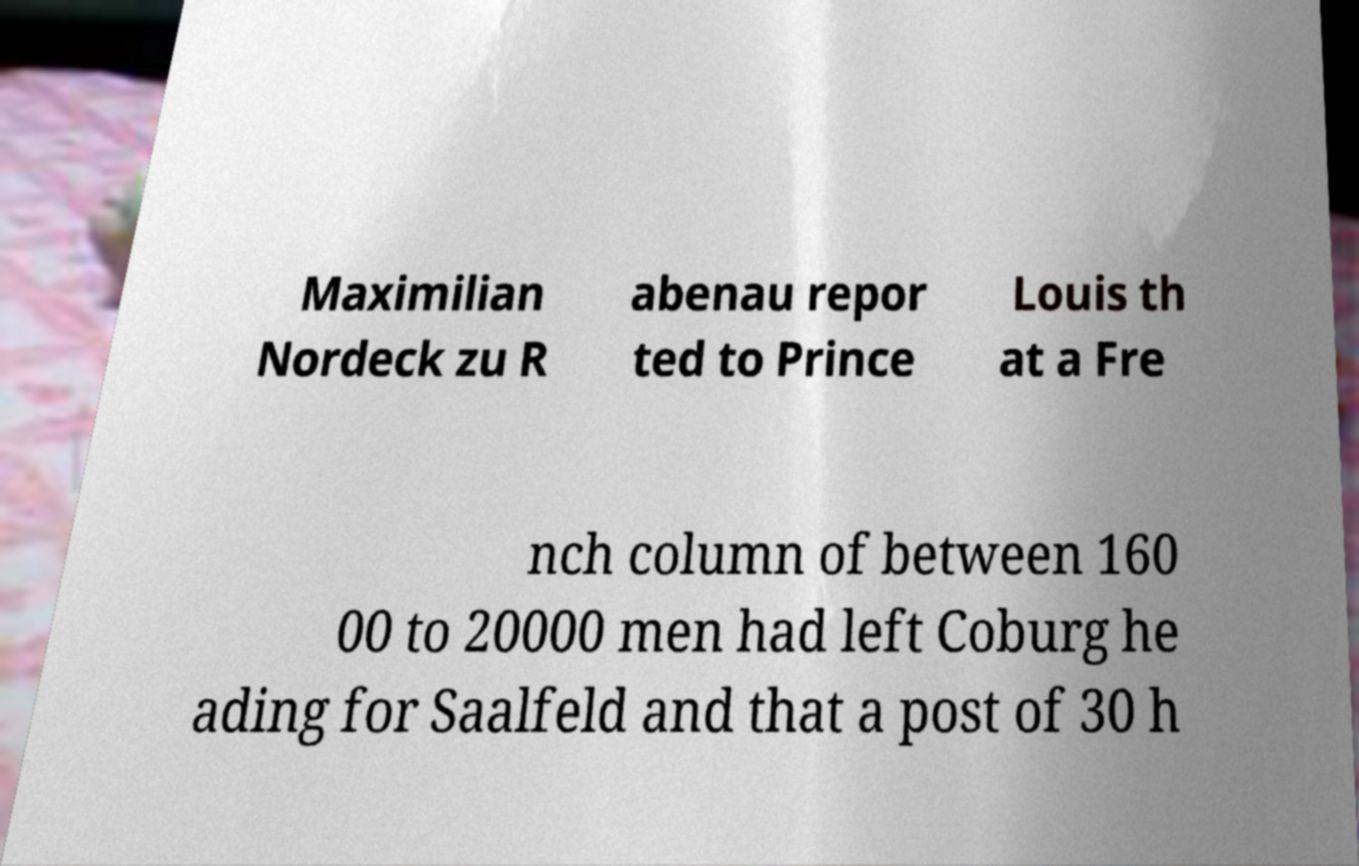Please read and relay the text visible in this image. What does it say? Maximilian Nordeck zu R abenau repor ted to Prince Louis th at a Fre nch column of between 160 00 to 20000 men had left Coburg he ading for Saalfeld and that a post of 30 h 